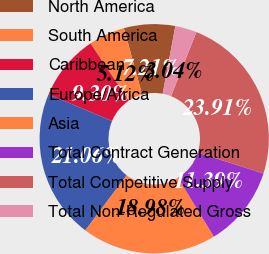Convert chart to OTSL. <chart><loc_0><loc_0><loc_500><loc_500><pie_chart><fcel>North America<fcel>South America<fcel>Caribbean<fcel>Europe/Africa<fcel>Asia<fcel>Total Contract Generation<fcel>Total Competitive Supply<fcel>Total Non-Regulated Gross<nl><fcel>7.21%<fcel>5.12%<fcel>9.3%<fcel>21.06%<fcel>18.98%<fcel>11.39%<fcel>23.91%<fcel>3.04%<nl></chart> 